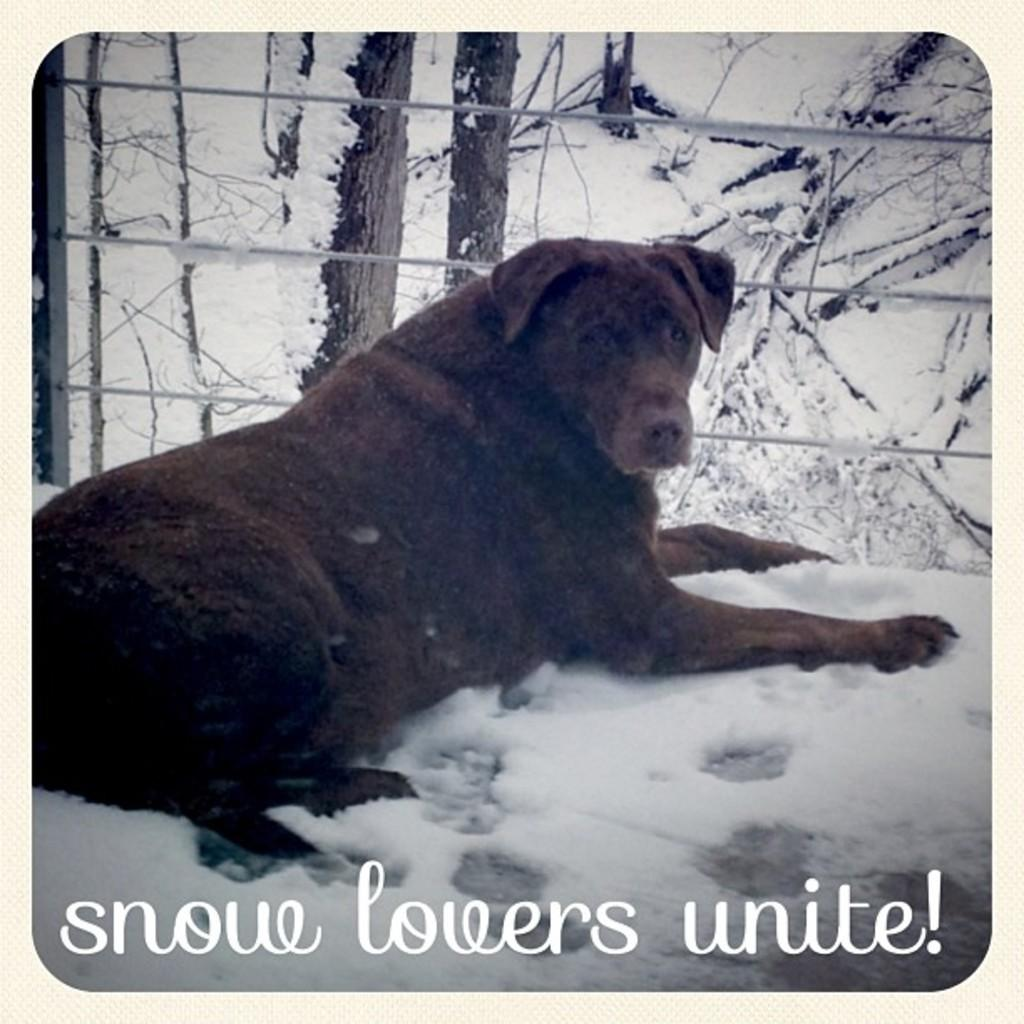What animal can be seen in the image? There is a dog in the image. Where is the dog located in relation to the fencing? The dog is in front of the fencing. What is written or displayed at the bottom of the image? There is text at the bottom of the image. What type of vegetation or object is visible at the top of the image? There are stems at the top of the image. What time does the dad's clock show in the image? There is no dad or clock present in the image. How many fish can be seen swimming in the image? There are no fish present in the image. 